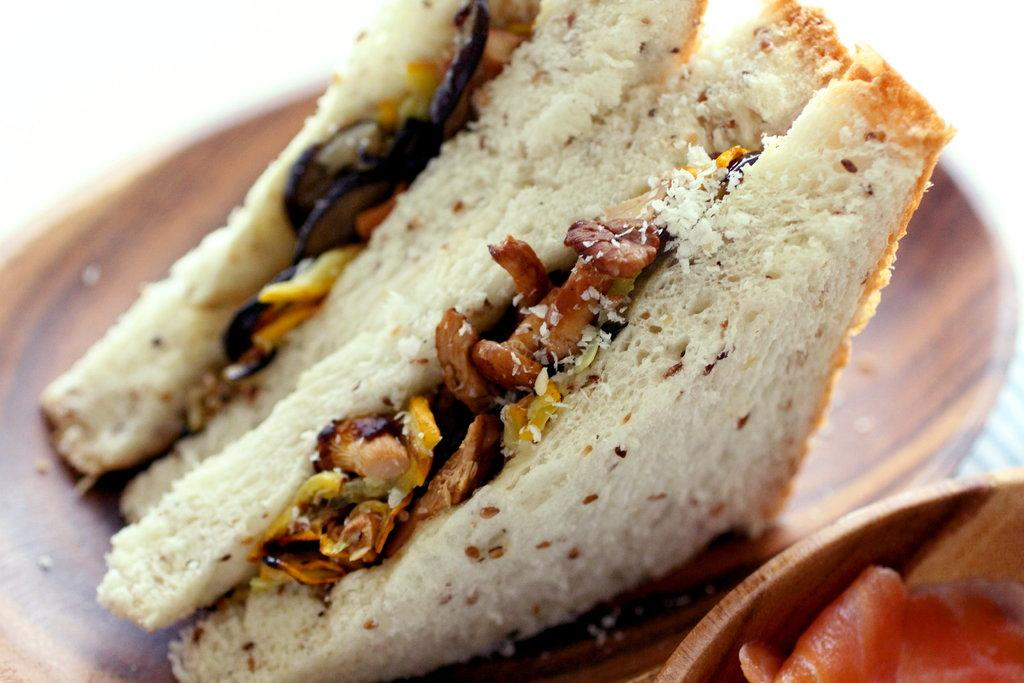What type of food can be seen in the image? There are two pieces of sandwiches in the image. Where are the sandwiches located? The sandwiches are on a plate. Is there any other food item visible in the image? Yes, there is a bowl with a food item in it at the bottom right side of the image. What type of bike can be seen in the image? There is no bike present in the image. Is there any wax visible in the image? There is no wax visible in the image. 